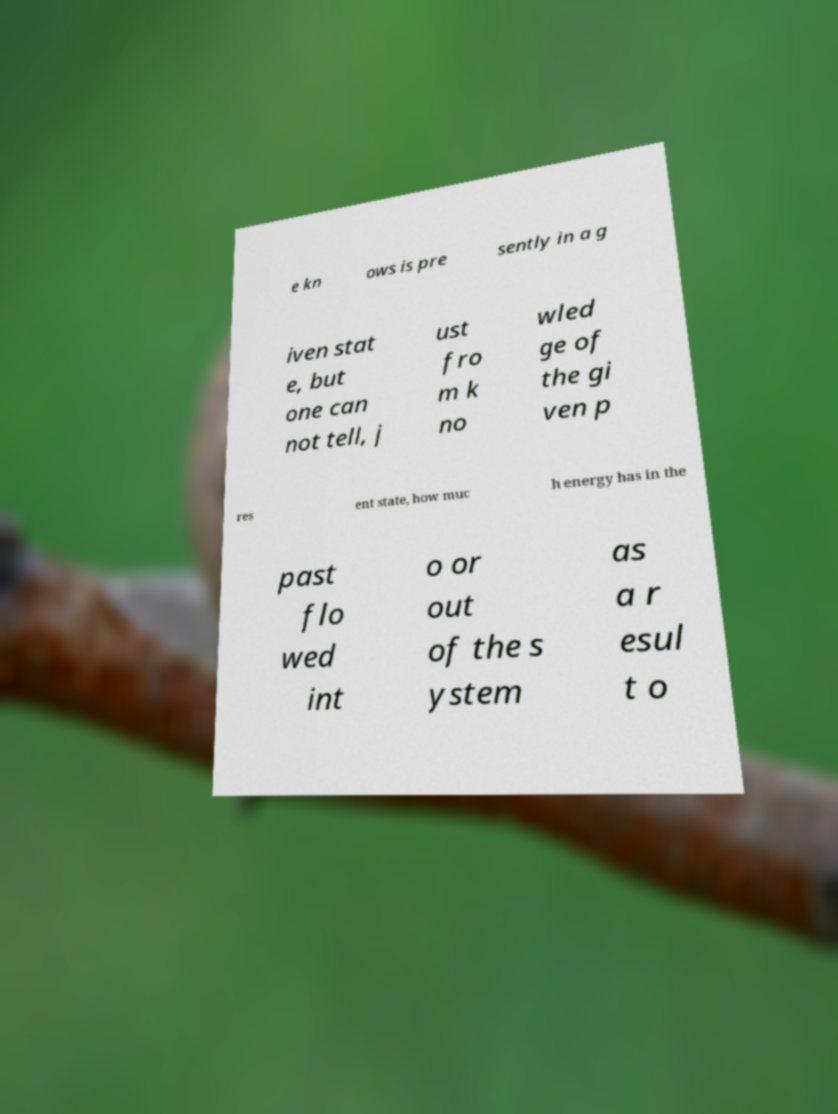Please identify and transcribe the text found in this image. e kn ows is pre sently in a g iven stat e, but one can not tell, j ust fro m k no wled ge of the gi ven p res ent state, how muc h energy has in the past flo wed int o or out of the s ystem as a r esul t o 